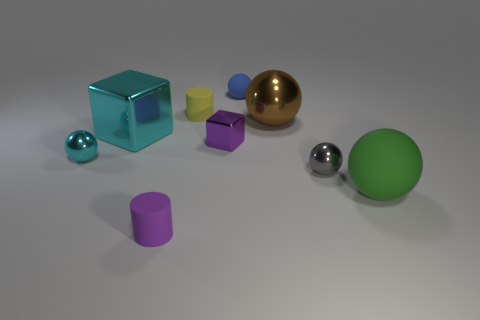There is a large shiny object that is behind the cyan metal block; is it the same color as the small cylinder that is to the left of the yellow cylinder?
Provide a succinct answer. No. Is the number of big green rubber things less than the number of yellow metallic blocks?
Provide a short and direct response. No. What shape is the tiny metal thing that is right of the sphere that is behind the yellow rubber thing?
Provide a succinct answer. Sphere. Are there any other things that have the same size as the blue rubber object?
Provide a succinct answer. Yes. What is the shape of the cyan object that is in front of the purple thing that is behind the cyan metallic sphere that is in front of the large cyan cube?
Offer a very short reply. Sphere. How many things are metal blocks that are on the left side of the purple matte thing or matte balls that are to the left of the large green matte ball?
Provide a short and direct response. 2. There is a yellow object; does it have the same size as the cyan thing in front of the large cube?
Offer a very short reply. Yes. Are the large brown ball that is in front of the tiny blue sphere and the small sphere that is left of the tiny purple cylinder made of the same material?
Your response must be concise. Yes. Are there an equal number of gray shiny things that are behind the tiny yellow thing and small cyan objects on the left side of the tiny cyan object?
Offer a very short reply. Yes. How many things are the same color as the big block?
Give a very brief answer. 1. 